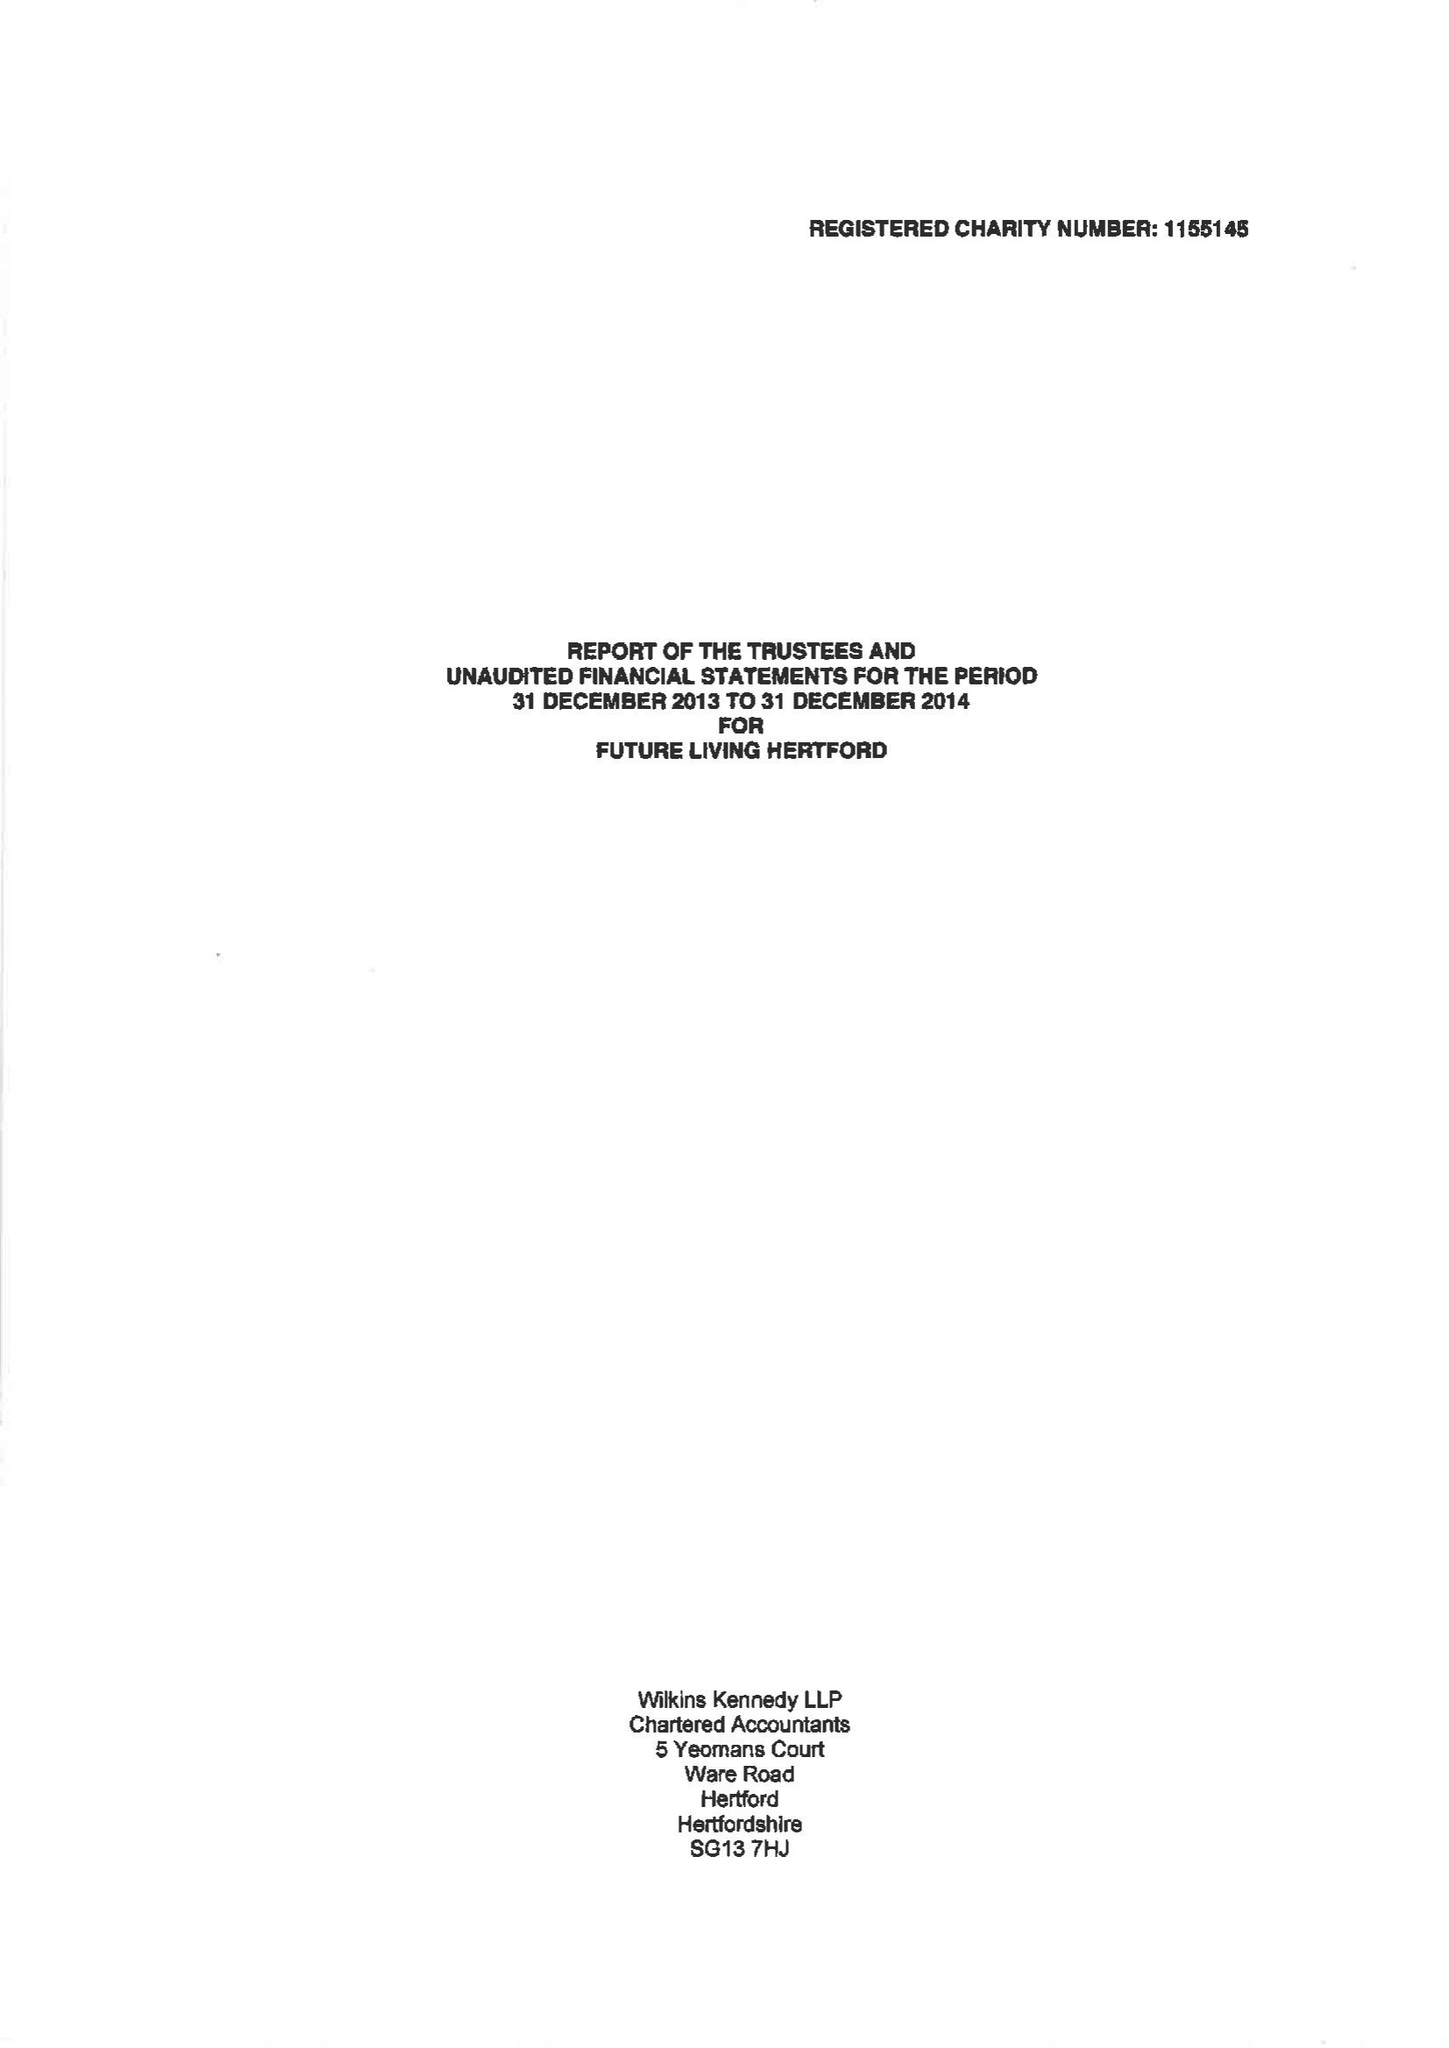What is the value for the spending_annually_in_british_pounds?
Answer the question using a single word or phrase. 24675.00 